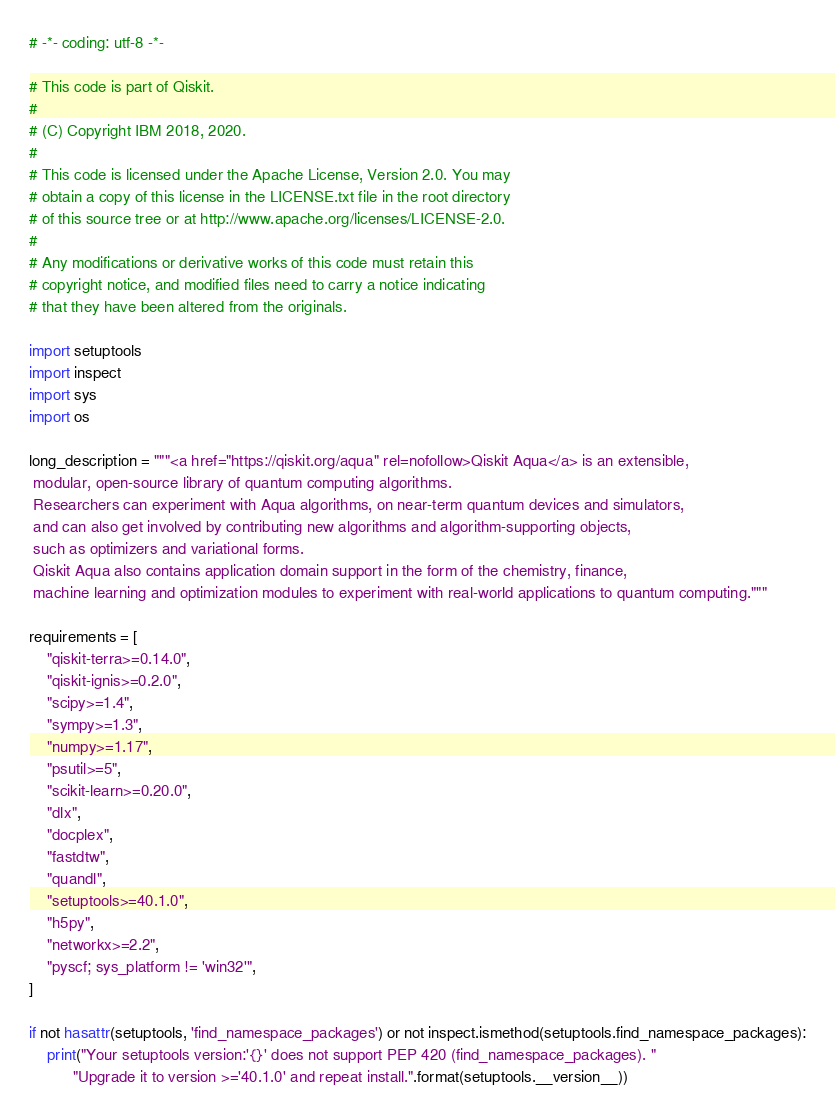Convert code to text. <code><loc_0><loc_0><loc_500><loc_500><_Python_># -*- coding: utf-8 -*-

# This code is part of Qiskit.
#
# (C) Copyright IBM 2018, 2020.
#
# This code is licensed under the Apache License, Version 2.0. You may
# obtain a copy of this license in the LICENSE.txt file in the root directory
# of this source tree or at http://www.apache.org/licenses/LICENSE-2.0.
#
# Any modifications or derivative works of this code must retain this
# copyright notice, and modified files need to carry a notice indicating
# that they have been altered from the originals.

import setuptools
import inspect
import sys
import os

long_description = """<a href="https://qiskit.org/aqua" rel=nofollow>Qiskit Aqua</a> is an extensible,
 modular, open-source library of quantum computing algorithms.
 Researchers can experiment with Aqua algorithms, on near-term quantum devices and simulators,
 and can also get involved by contributing new algorithms and algorithm-supporting objects,
 such as optimizers and variational forms.
 Qiskit Aqua also contains application domain support in the form of the chemistry, finance,
 machine learning and optimization modules to experiment with real-world applications to quantum computing."""

requirements = [
    "qiskit-terra>=0.14.0",
    "qiskit-ignis>=0.2.0",
    "scipy>=1.4",
    "sympy>=1.3",
    "numpy>=1.17",
    "psutil>=5",
    "scikit-learn>=0.20.0",
    "dlx",
    "docplex",
    "fastdtw",
    "quandl",
    "setuptools>=40.1.0",
    "h5py",
    "networkx>=2.2",
    "pyscf; sys_platform != 'win32'",
]

if not hasattr(setuptools, 'find_namespace_packages') or not inspect.ismethod(setuptools.find_namespace_packages):
    print("Your setuptools version:'{}' does not support PEP 420 (find_namespace_packages). "
          "Upgrade it to version >='40.1.0' and repeat install.".format(setuptools.__version__))</code> 